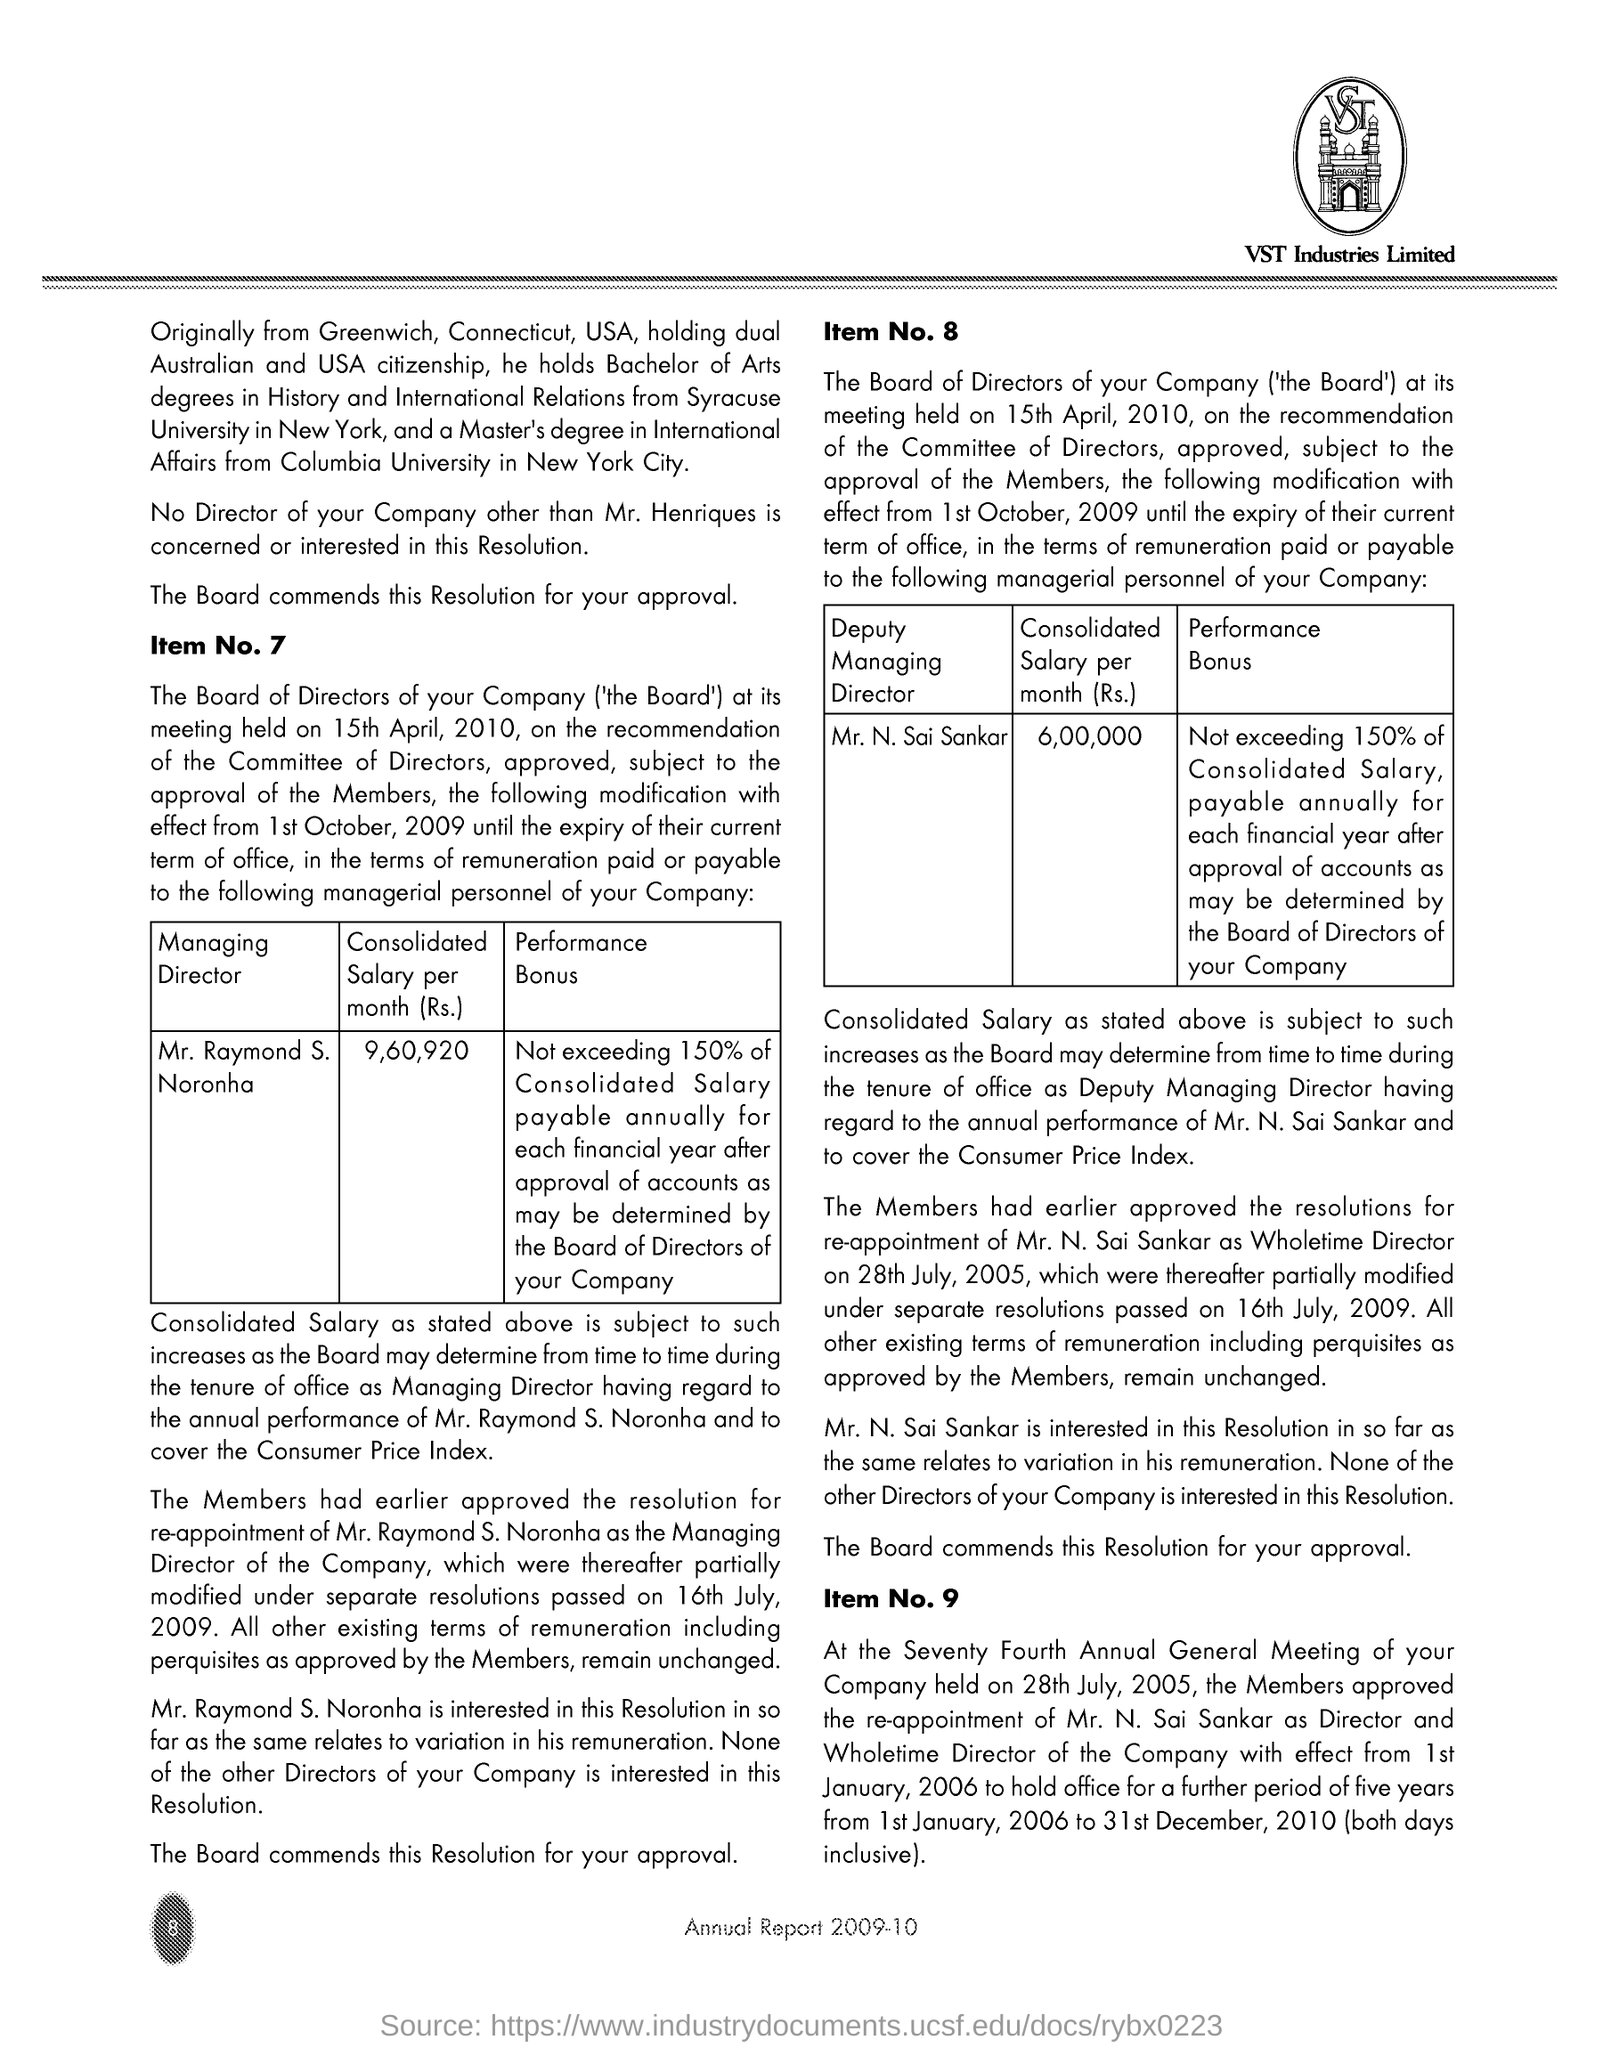Identify some key points in this picture. The consolidated salary of Mr. Raymond S Norantha is 9,60,920. 